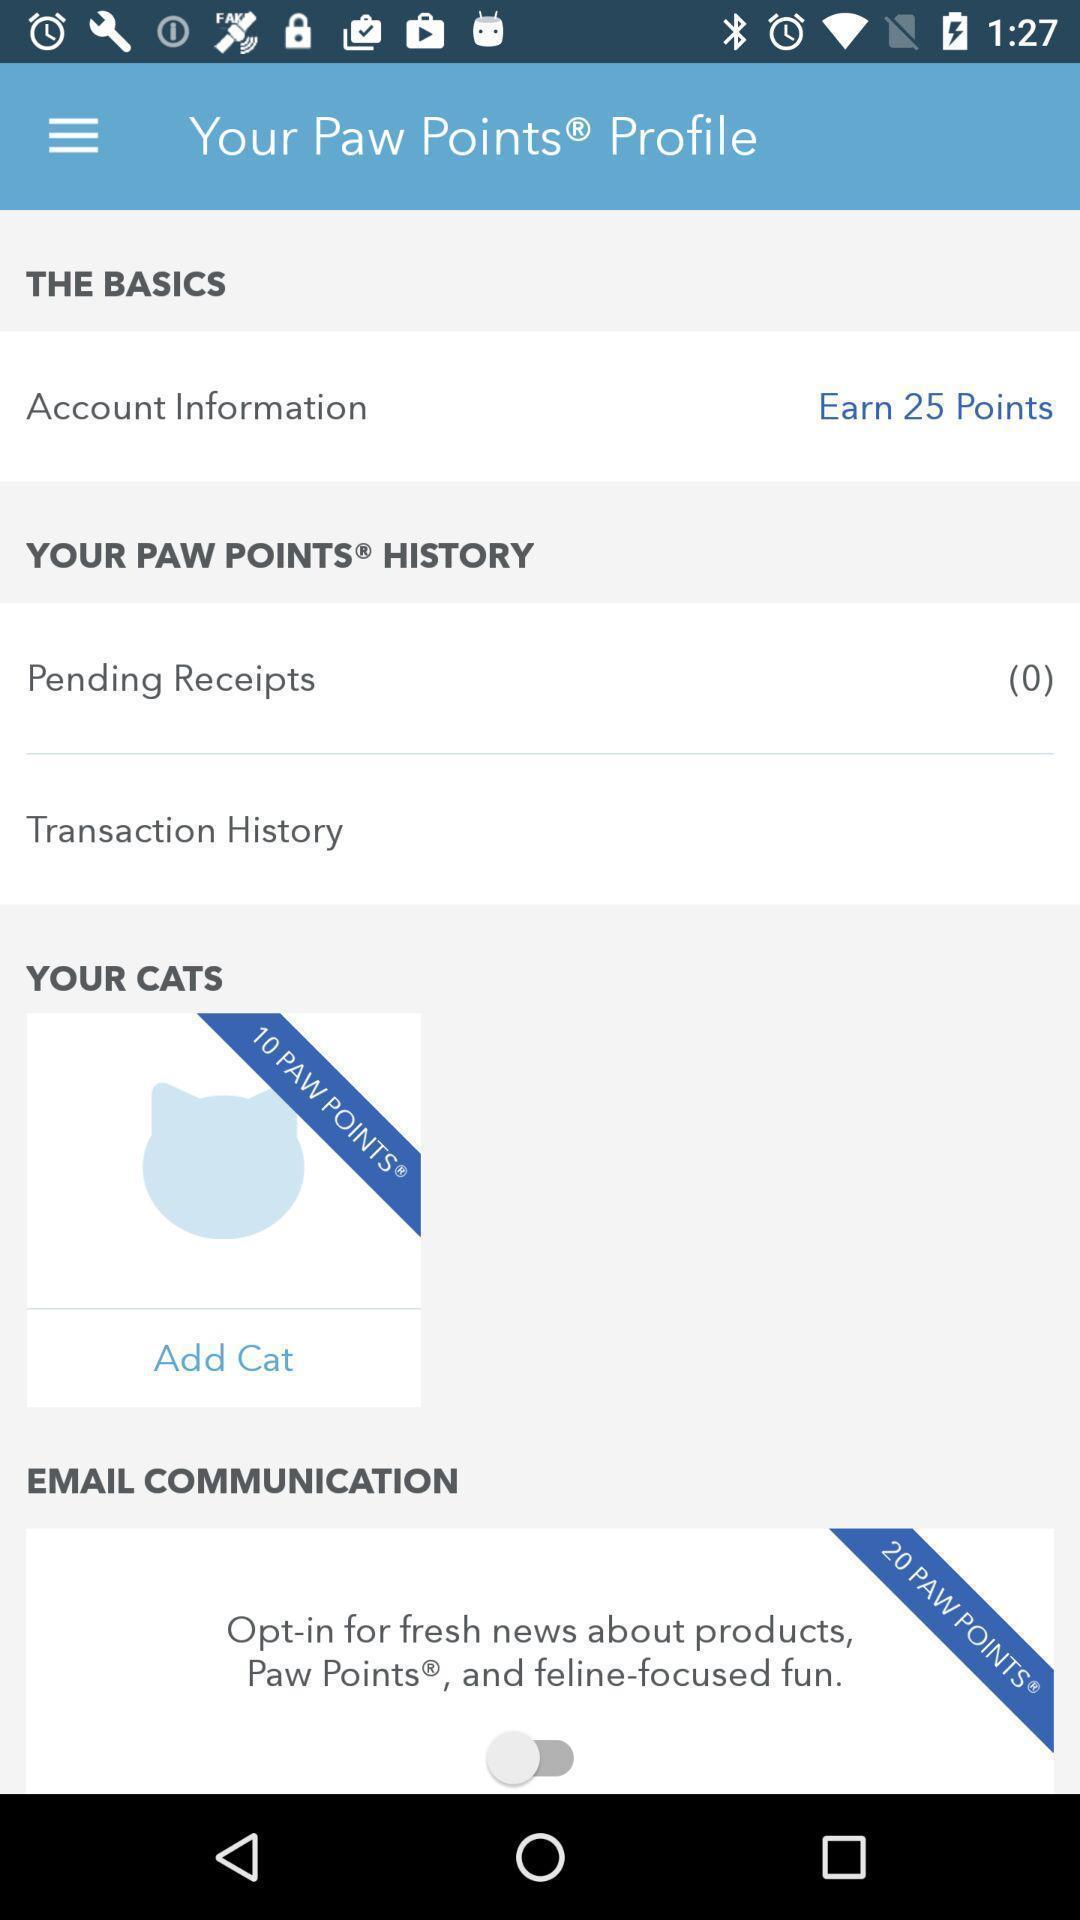What details can you identify in this image? Screen displaying the profile page. 